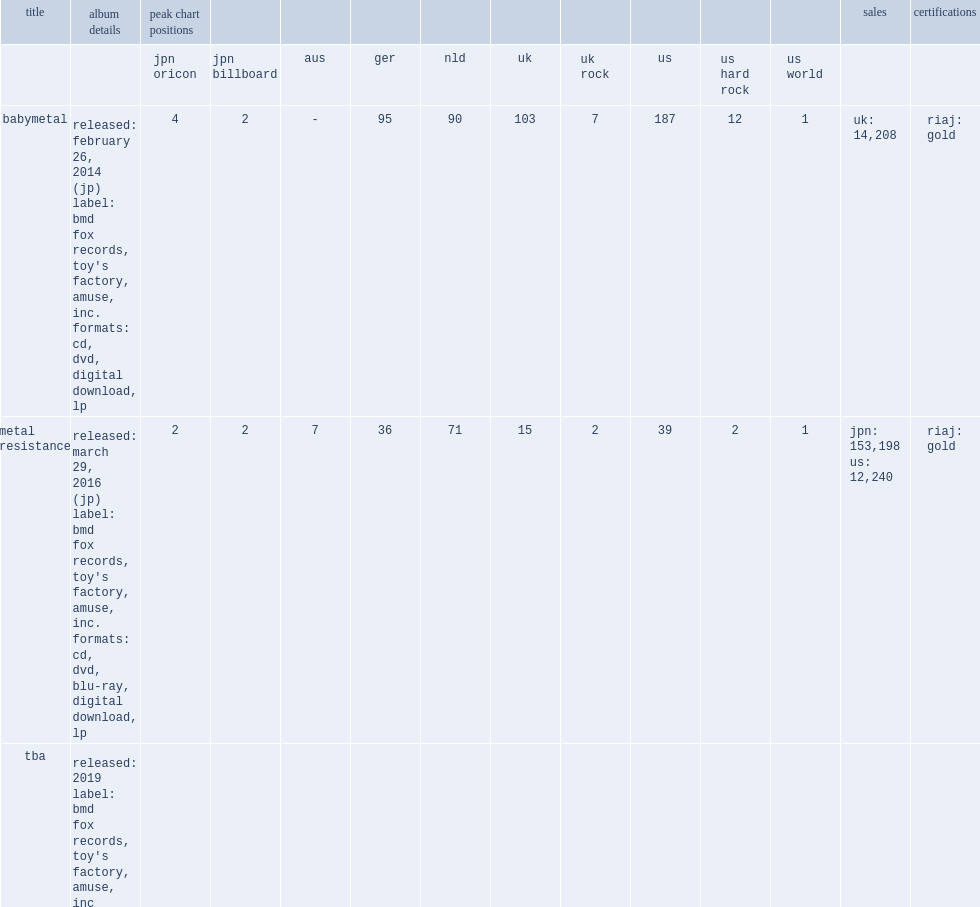What was the number of babymetal reached on the us chart? 187.0. 